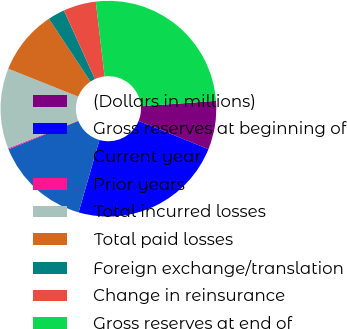Convert chart. <chart><loc_0><loc_0><loc_500><loc_500><pie_chart><fcel>(Dollars in millions)<fcel>Gross reserves at beginning of<fcel>Current year<fcel>Prior years<fcel>Total incurred losses<fcel>Total paid losses<fcel>Foreign exchange/translation<fcel>Change in reinsurance<fcel>Gross reserves at end of<nl><fcel>7.28%<fcel>23.34%<fcel>14.4%<fcel>0.16%<fcel>12.03%<fcel>9.65%<fcel>2.53%<fcel>4.9%<fcel>25.71%<nl></chart> 